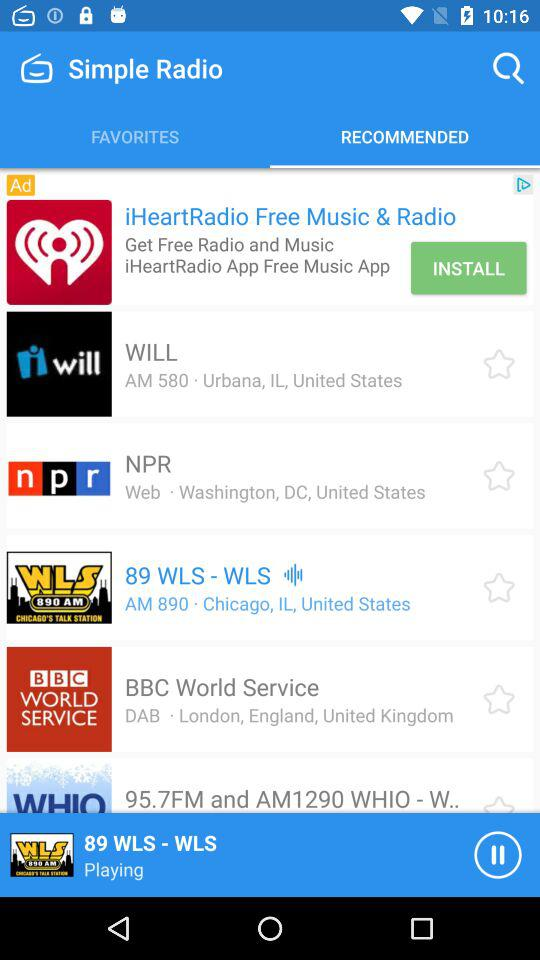What is the location of NPR? The location of NPR is Washington, DC, United States. 